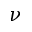Convert formula to latex. <formula><loc_0><loc_0><loc_500><loc_500>\nu</formula> 